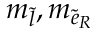<formula> <loc_0><loc_0><loc_500><loc_500>m _ { \tilde { l } } , m _ { { \tilde { e } } _ { R } }</formula> 